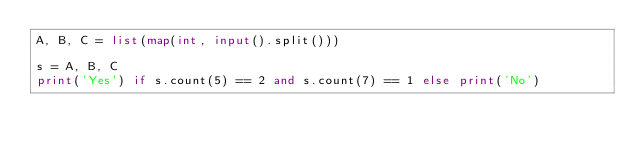<code> <loc_0><loc_0><loc_500><loc_500><_Python_>A, B, C = list(map(int, input().split()))

s = A, B, C
print('Yes') if s.count(5) == 2 and s.count(7) == 1 else print('No')</code> 